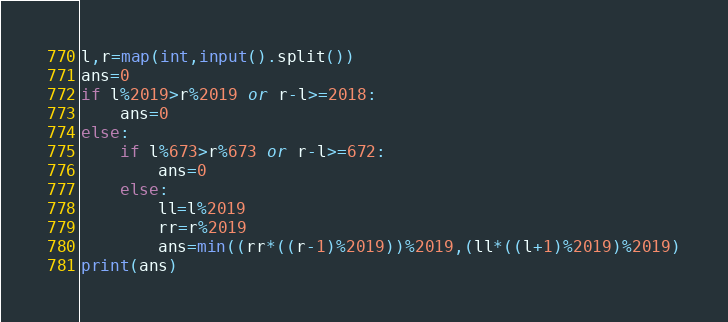<code> <loc_0><loc_0><loc_500><loc_500><_Python_>l,r=map(int,input().split())
ans=0
if l%2019>r%2019 or r-l>=2018:
    ans=0
else:
    if l%673>r%673 or r-l>=672:
        ans=0
    else:
        ll=l%2019
        rr=r%2019
        ans=min((rr*((r-1)%2019))%2019,(ll*((l+1)%2019)%2019)
print(ans)</code> 